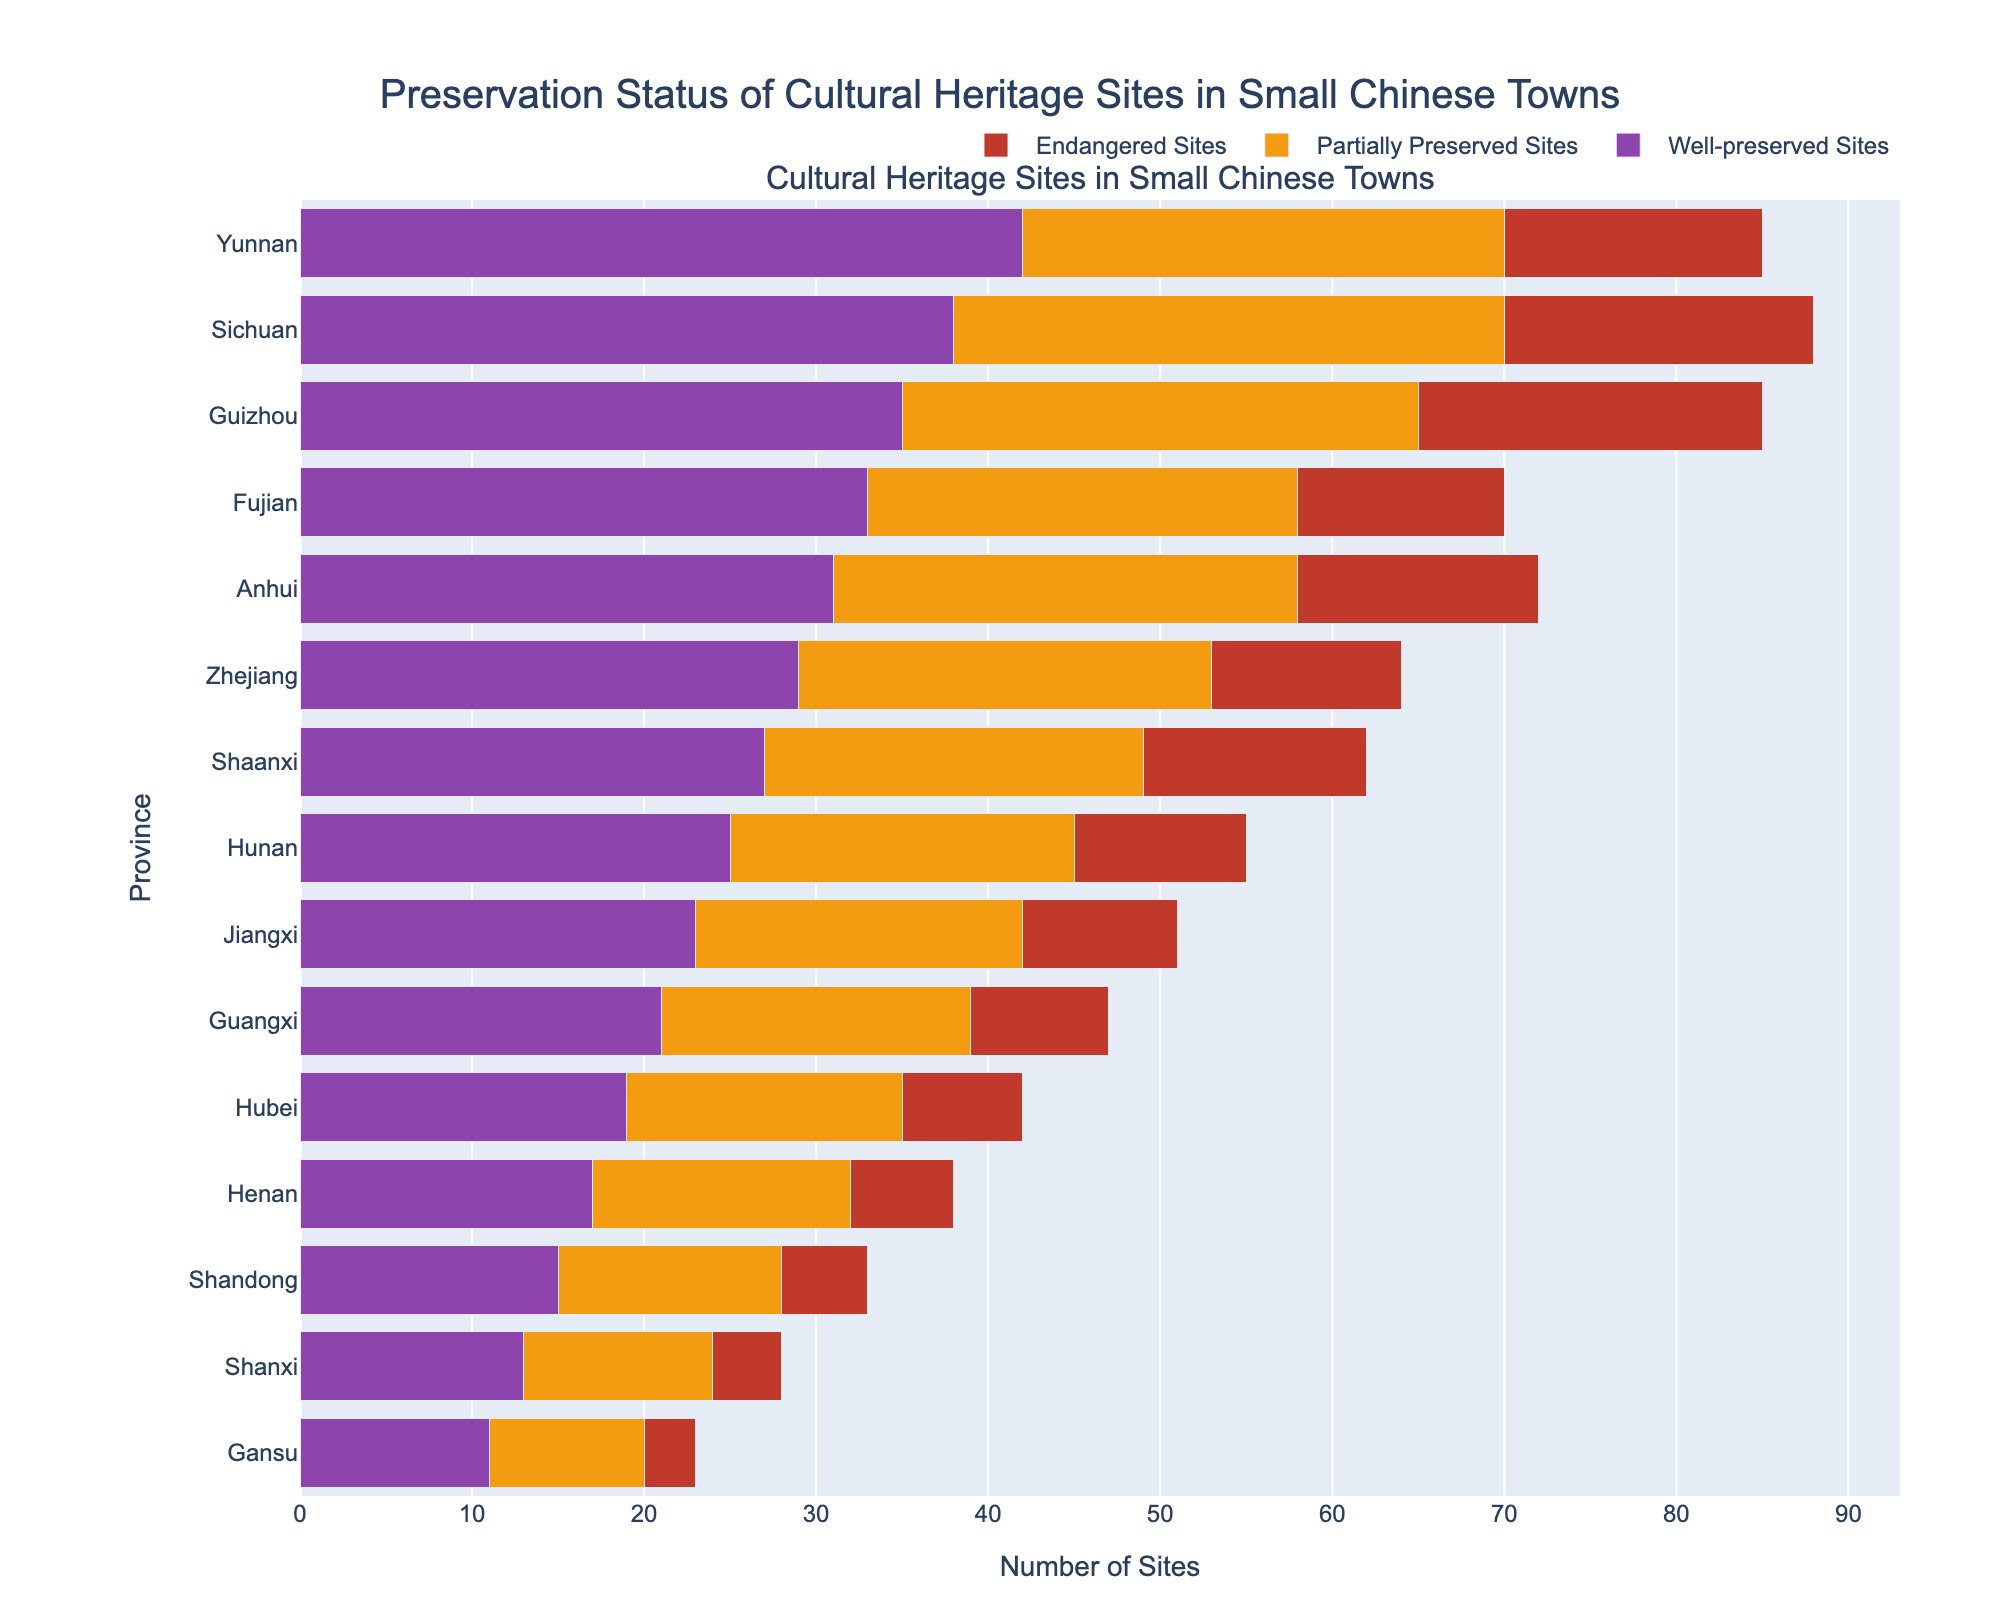Which province has the highest number of well-preserved cultural heritage sites? Look at the bars for well-preserved sites and identify the longest bar. Yunnan has the longest bar.
Answer: Yunnan Which province has more well-preserved sites: Zhejiang or Anhui? Compare the lengths of the well-preserved sites bars for Zhejiang and Anhui. Anhui’s bar is longer.
Answer: Anhui What is the total number of cultural heritage sites (all categories combined) in Guizhou? Add the three categories for Guizhou: Well-preserved Sites (35) + Partially Preserved Sites (30) + Endangered Sites (20) = 85.
Answer: 85 Compare Hunan and Jiangxi in terms of the number of partially preserved sites. Which has more? Look at the length of the partially preserved sites bars for both Hunan and Jiangxi. Hunan’s bar is longer.
Answer: Hunan What is the sum of endangered sites in Yunnan, Sichuan, and Guizhou? Add the endangered sites from these provinces: Yunnan (15) + Sichuan (18) + Guizhou (20) = 53.
Answer: 53 Is the number of partially preserved sites in Shaanxi equal to the number of well-preserved sites in Fujian? Compare the bars for partially preserved sites in Shaanxi (22) and well-preserved sites in Fujian (33). They are not equal.
Answer: No How many more well-preserved sites does Yunnan have compared to Gansu? Subtract the well-preserved sites in Gansu (11) from those in Yunnan (42): 42 - 11 = 31.
Answer: 31 Which province has the least number of endangered sites? Identify the shortest bar in the endangered sites category. Gansu has the shortest bar.
Answer: Gansu What is the average number of well-preserved sites in Henan, Shandong, and Shanxi? Add the well-preserved sites in Henan (17), Shandong (15), and Shanxi (13): 17 + 15 + 13 = 45, then divide by 3: 45 / 3 = 15.
Answer: 15 Which province has a higher combined total of well-preserved and partially preserved sites: Fujian or Anhui? Sum the well-preserved and partially preserved sites for both provinces: Fujian (33 + 25 = 58) and Anhui (31 + 27 = 58). Both totals are the same.
Answer: Both are equal 